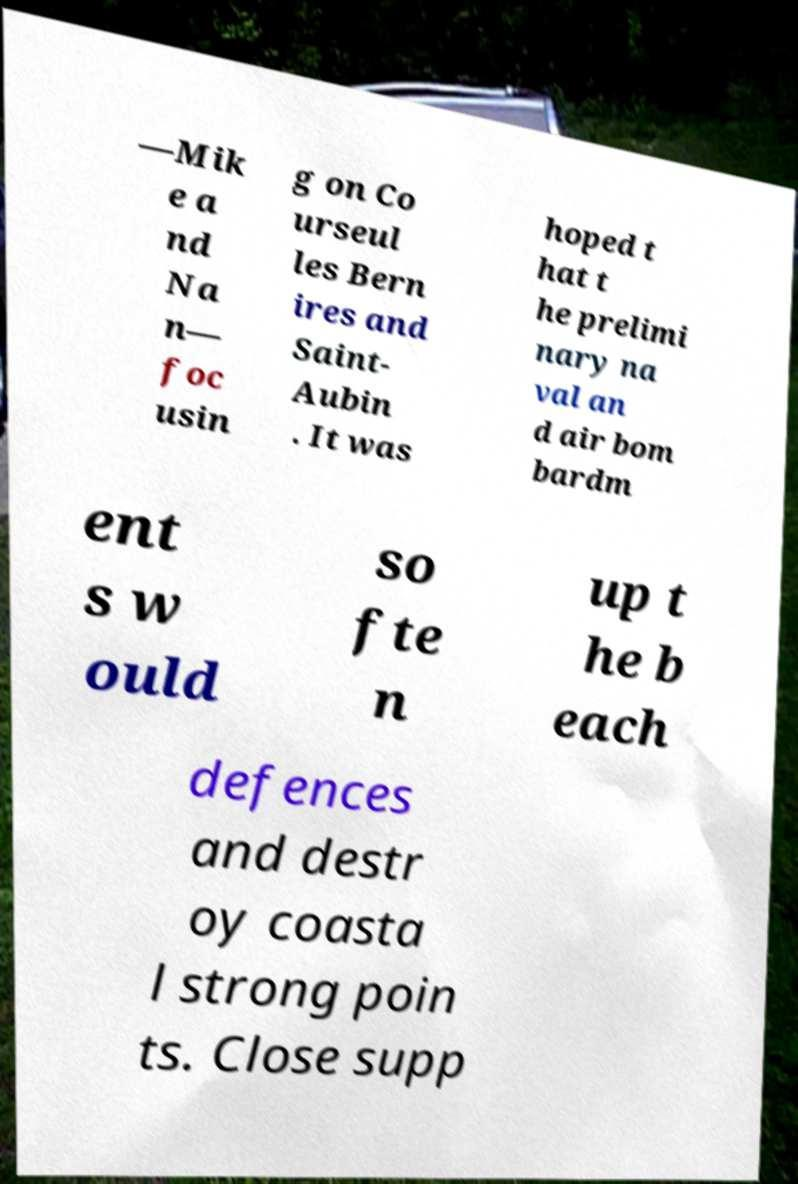Please identify and transcribe the text found in this image. —Mik e a nd Na n— foc usin g on Co urseul les Bern ires and Saint- Aubin . It was hoped t hat t he prelimi nary na val an d air bom bardm ent s w ould so fte n up t he b each defences and destr oy coasta l strong poin ts. Close supp 